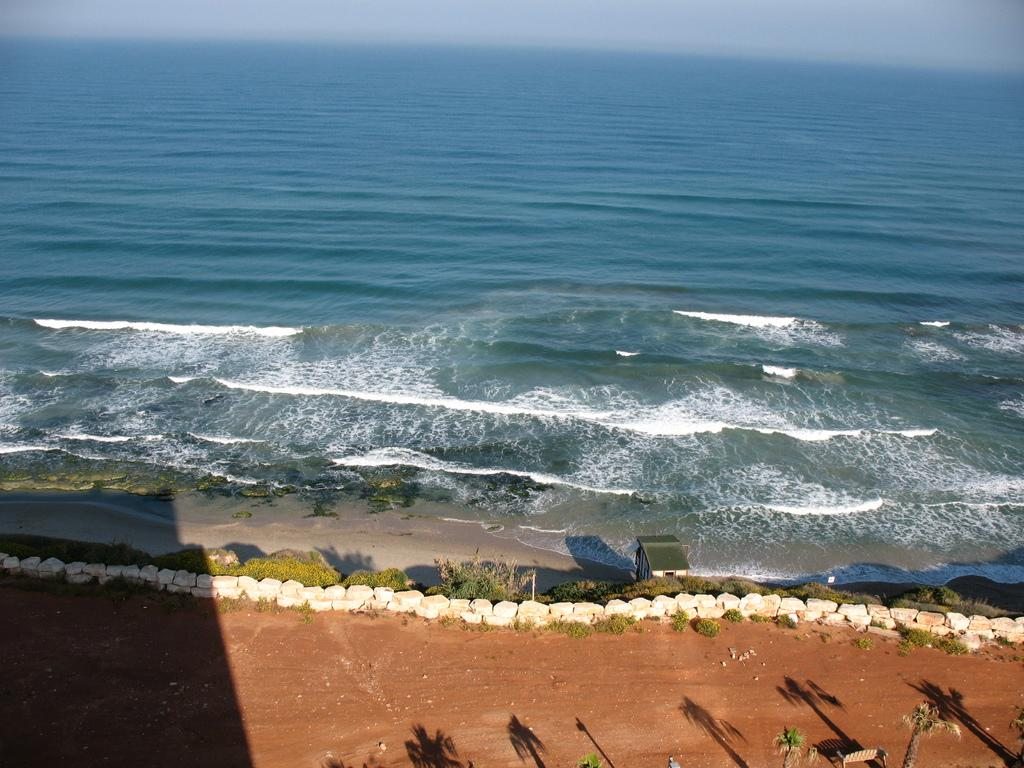What type of vegetation can be seen in the image? There are trees in the image. What type of structure is present in the image? There is a stone wall in the image. What natural element is visible in the image? Water is visible in the image. What is visible in the background of the image? The sky is visible in the background of the image. What is the opinion of the trees about the stone wall in the image? Trees do not have opinions, as they are inanimate objects. Can you tell me where the frame of the image is located? The frame of the image is not visible in the image itself, as it is a part of the physical photograph or digital file. 